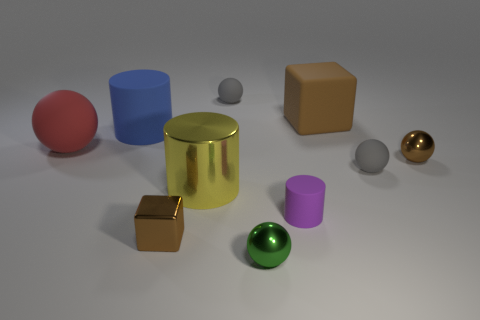Subtract all large matte cylinders. How many cylinders are left? 2 Subtract all green spheres. How many spheres are left? 4 Subtract 2 cubes. How many cubes are left? 0 Subtract all cylinders. How many objects are left? 7 Subtract all yellow cylinders. How many gray spheres are left? 2 Subtract all big green things. Subtract all tiny things. How many objects are left? 4 Add 4 yellow metallic things. How many yellow metallic things are left? 5 Add 10 small red cubes. How many small red cubes exist? 10 Subtract 1 purple cylinders. How many objects are left? 9 Subtract all red cylinders. Subtract all cyan balls. How many cylinders are left? 3 